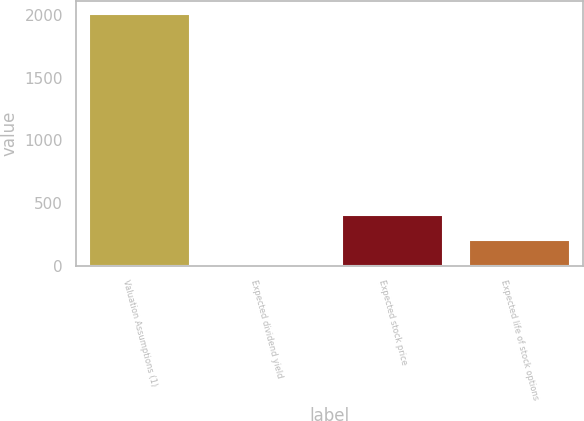<chart> <loc_0><loc_0><loc_500><loc_500><bar_chart><fcel>Valuation Assumptions (1)<fcel>Expected dividend yield<fcel>Expected stock price<fcel>Expected life of stock options<nl><fcel>2010<fcel>1.6<fcel>403.28<fcel>202.44<nl></chart> 